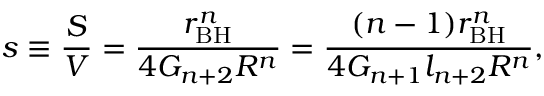<formula> <loc_0><loc_0><loc_500><loc_500>s \equiv \frac { S } { V } = \frac { r _ { B H } ^ { n } } { 4 G _ { n + 2 } R ^ { n } } = \frac { ( n - 1 ) r _ { B H } ^ { n } } { 4 G _ { n + 1 } l _ { n + 2 } R ^ { n } } ,</formula> 